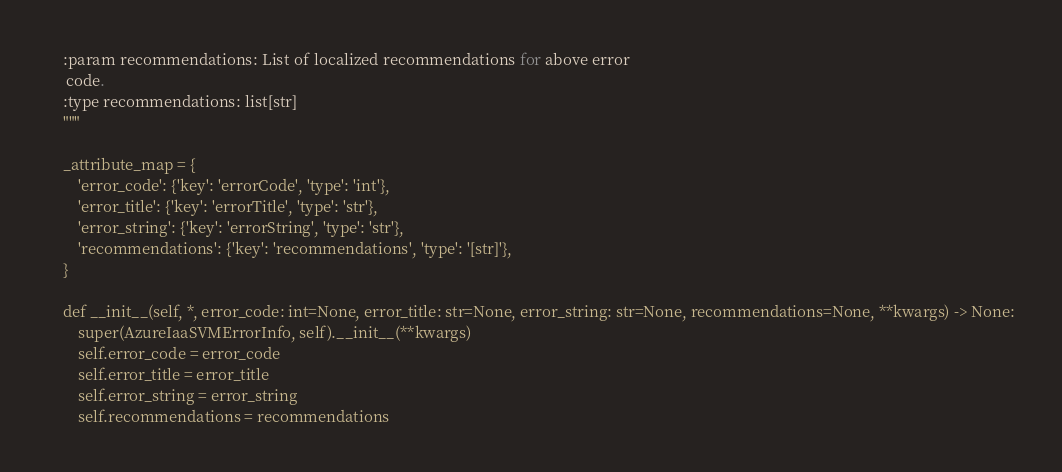Convert code to text. <code><loc_0><loc_0><loc_500><loc_500><_Python_>    :param recommendations: List of localized recommendations for above error
     code.
    :type recommendations: list[str]
    """

    _attribute_map = {
        'error_code': {'key': 'errorCode', 'type': 'int'},
        'error_title': {'key': 'errorTitle', 'type': 'str'},
        'error_string': {'key': 'errorString', 'type': 'str'},
        'recommendations': {'key': 'recommendations', 'type': '[str]'},
    }

    def __init__(self, *, error_code: int=None, error_title: str=None, error_string: str=None, recommendations=None, **kwargs) -> None:
        super(AzureIaaSVMErrorInfo, self).__init__(**kwargs)
        self.error_code = error_code
        self.error_title = error_title
        self.error_string = error_string
        self.recommendations = recommendations
</code> 